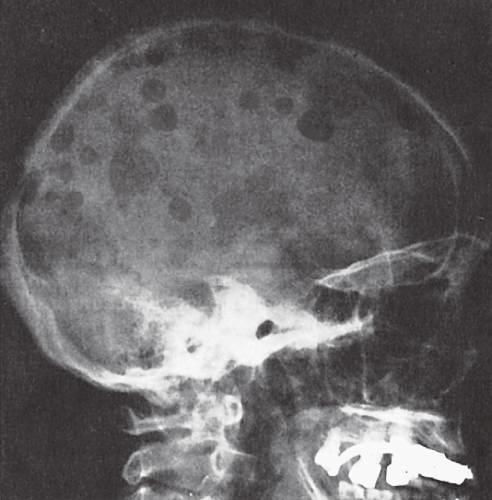re the sharply punched-out bone defects most obvious in the calvaria?
Answer the question using a single word or phrase. Yes 